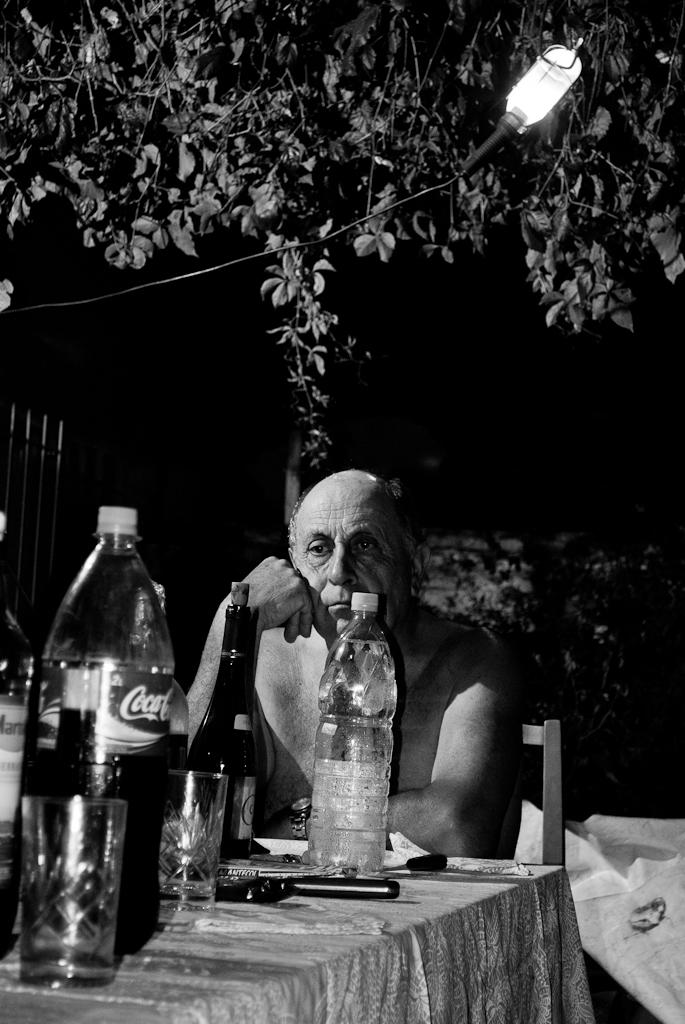What soda is on the table?
Your response must be concise. Coca cola. 